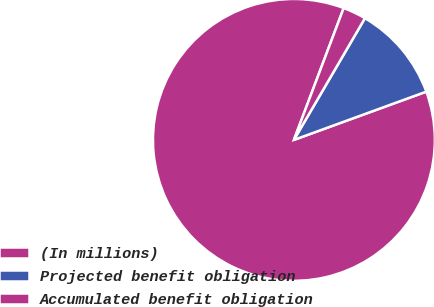Convert chart. <chart><loc_0><loc_0><loc_500><loc_500><pie_chart><fcel>(In millions)<fcel>Projected benefit obligation<fcel>Accumulated benefit obligation<nl><fcel>86.31%<fcel>11.03%<fcel>2.66%<nl></chart> 